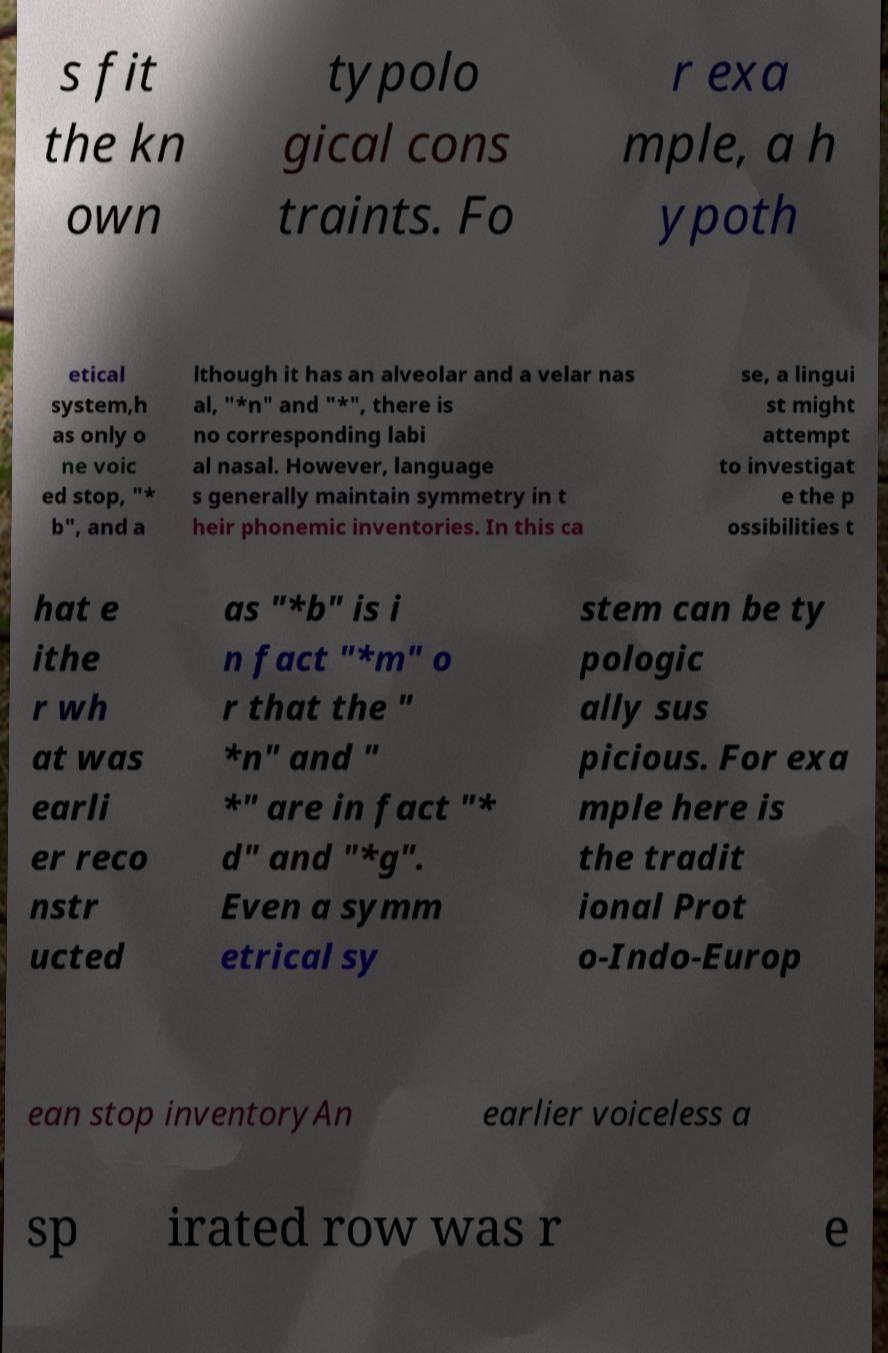Could you assist in decoding the text presented in this image and type it out clearly? s fit the kn own typolo gical cons traints. Fo r exa mple, a h ypoth etical system,h as only o ne voic ed stop, "* b", and a lthough it has an alveolar and a velar nas al, "*n" and "*", there is no corresponding labi al nasal. However, language s generally maintain symmetry in t heir phonemic inventories. In this ca se, a lingui st might attempt to investigat e the p ossibilities t hat e ithe r wh at was earli er reco nstr ucted as "*b" is i n fact "*m" o r that the " *n" and " *" are in fact "* d" and "*g". Even a symm etrical sy stem can be ty pologic ally sus picious. For exa mple here is the tradit ional Prot o-Indo-Europ ean stop inventoryAn earlier voiceless a sp irated row was r e 